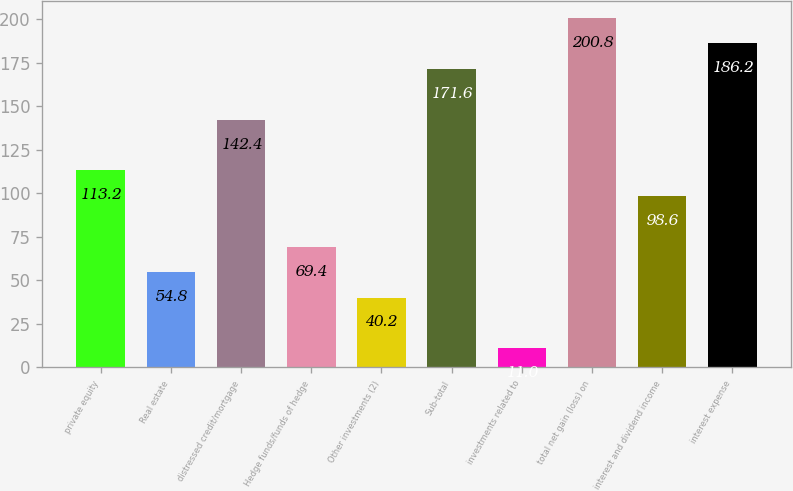Convert chart. <chart><loc_0><loc_0><loc_500><loc_500><bar_chart><fcel>private equity<fcel>Real estate<fcel>distressed credit/mortgage<fcel>Hedge funds/funds of hedge<fcel>Other investments (2)<fcel>Sub-total<fcel>investments related to<fcel>total net gain (loss) on<fcel>interest and dividend income<fcel>interest expense<nl><fcel>113.2<fcel>54.8<fcel>142.4<fcel>69.4<fcel>40.2<fcel>171.6<fcel>11<fcel>200.8<fcel>98.6<fcel>186.2<nl></chart> 